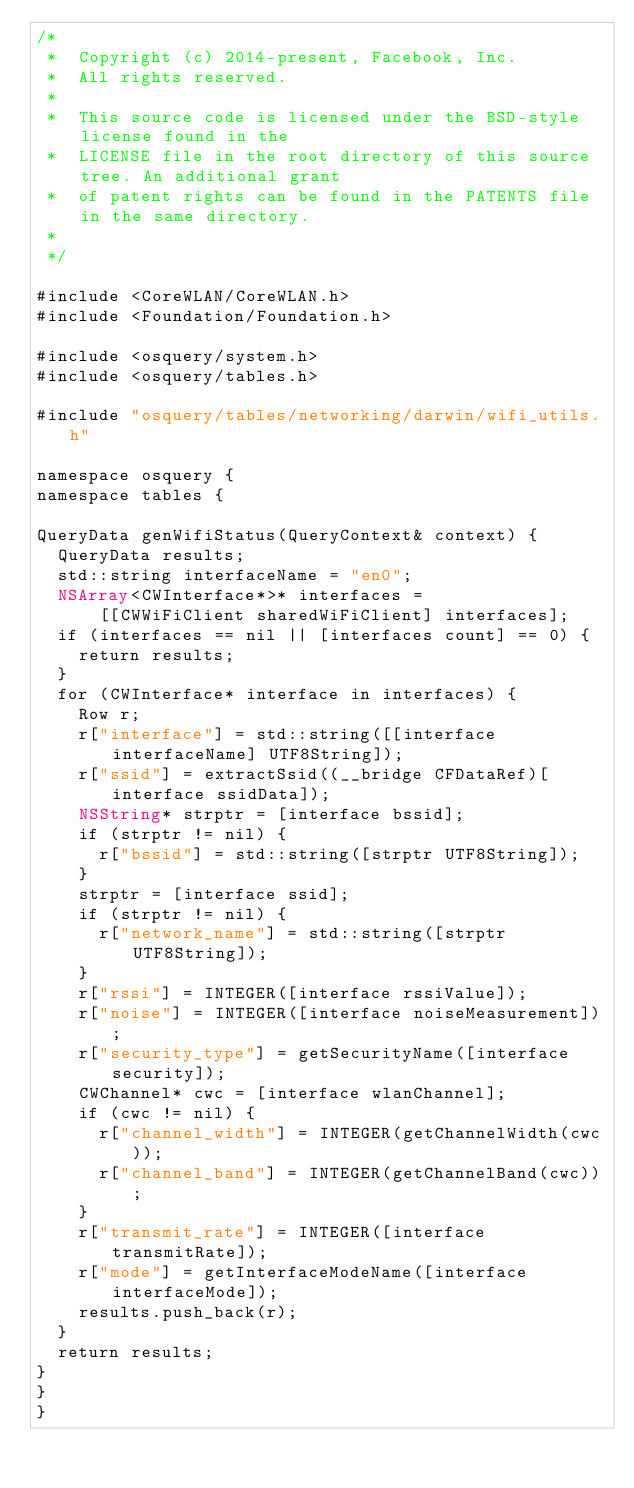Convert code to text. <code><loc_0><loc_0><loc_500><loc_500><_ObjectiveC_>/*
 *  Copyright (c) 2014-present, Facebook, Inc.
 *  All rights reserved.
 *
 *  This source code is licensed under the BSD-style license found in the
 *  LICENSE file in the root directory of this source tree. An additional grant
 *  of patent rights can be found in the PATENTS file in the same directory.
 *
 */

#include <CoreWLAN/CoreWLAN.h>
#include <Foundation/Foundation.h>

#include <osquery/system.h>
#include <osquery/tables.h>

#include "osquery/tables/networking/darwin/wifi_utils.h"

namespace osquery {
namespace tables {

QueryData genWifiStatus(QueryContext& context) {
  QueryData results;
  std::string interfaceName = "en0";
  NSArray<CWInterface*>* interfaces =
      [[CWWiFiClient sharedWiFiClient] interfaces];
  if (interfaces == nil || [interfaces count] == 0) {
    return results;
  }
  for (CWInterface* interface in interfaces) {
    Row r;
    r["interface"] = std::string([[interface interfaceName] UTF8String]);
    r["ssid"] = extractSsid((__bridge CFDataRef)[interface ssidData]);
    NSString* strptr = [interface bssid];
    if (strptr != nil) {
      r["bssid"] = std::string([strptr UTF8String]);
    }
    strptr = [interface ssid];
    if (strptr != nil) {
      r["network_name"] = std::string([strptr UTF8String]);
    }
    r["rssi"] = INTEGER([interface rssiValue]);
    r["noise"] = INTEGER([interface noiseMeasurement]);
    r["security_type"] = getSecurityName([interface security]);
    CWChannel* cwc = [interface wlanChannel];
    if (cwc != nil) {
      r["channel_width"] = INTEGER(getChannelWidth(cwc));
      r["channel_band"] = INTEGER(getChannelBand(cwc));
    }
    r["transmit_rate"] = INTEGER([interface transmitRate]);
    r["mode"] = getInterfaceModeName([interface interfaceMode]);
    results.push_back(r);
  }
  return results;
}
}
}
</code> 